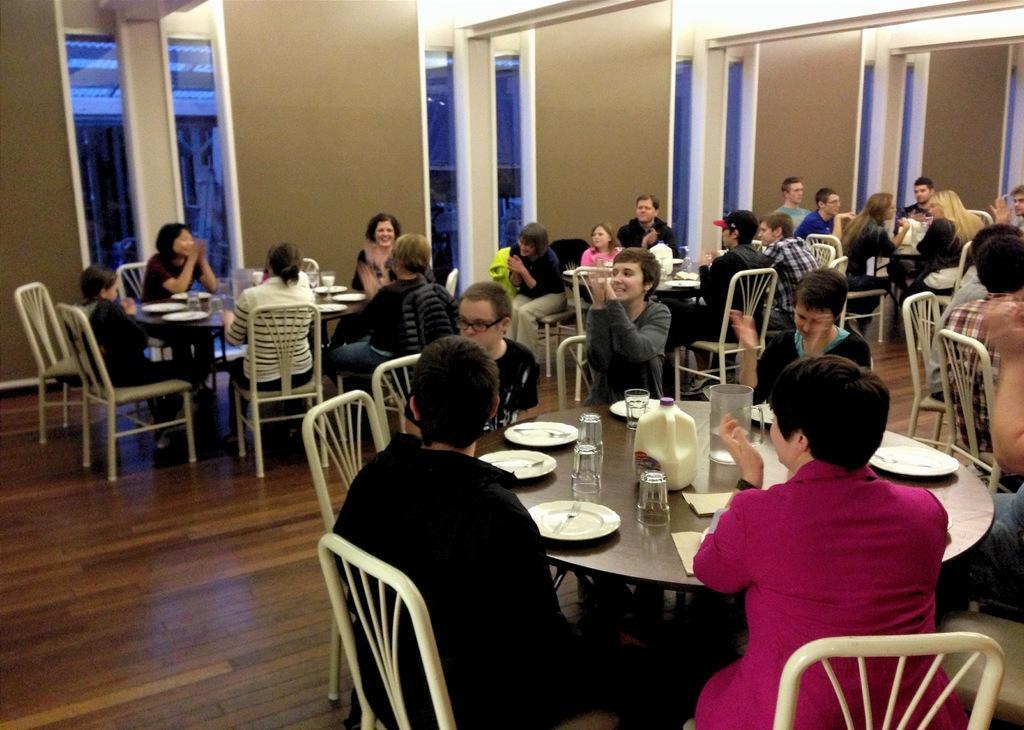How would you summarize this image in a sentence or two? In this image I can see few tables and number of people are sitting on chairs. On these tables I can see number of plates, glasses and few bottles. 